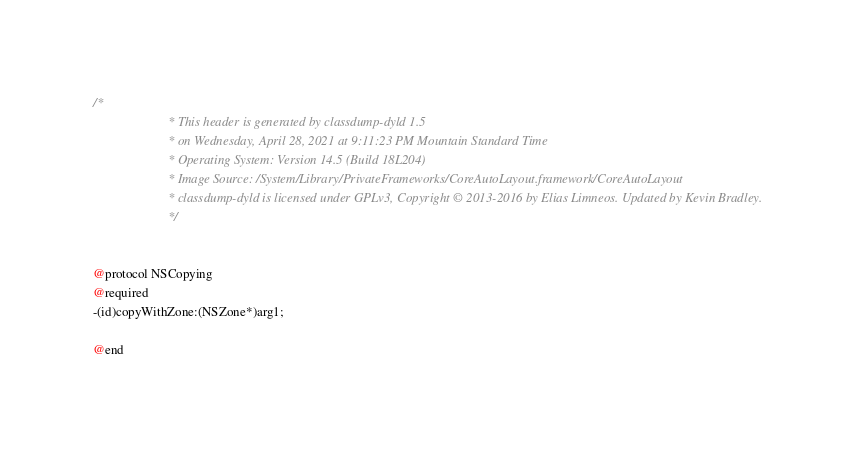<code> <loc_0><loc_0><loc_500><loc_500><_C_>/*
                       * This header is generated by classdump-dyld 1.5
                       * on Wednesday, April 28, 2021 at 9:11:23 PM Mountain Standard Time
                       * Operating System: Version 14.5 (Build 18L204)
                       * Image Source: /System/Library/PrivateFrameworks/CoreAutoLayout.framework/CoreAutoLayout
                       * classdump-dyld is licensed under GPLv3, Copyright © 2013-2016 by Elias Limneos. Updated by Kevin Bradley.
                       */


@protocol NSCopying
@required
-(id)copyWithZone:(NSZone*)arg1;

@end

</code> 